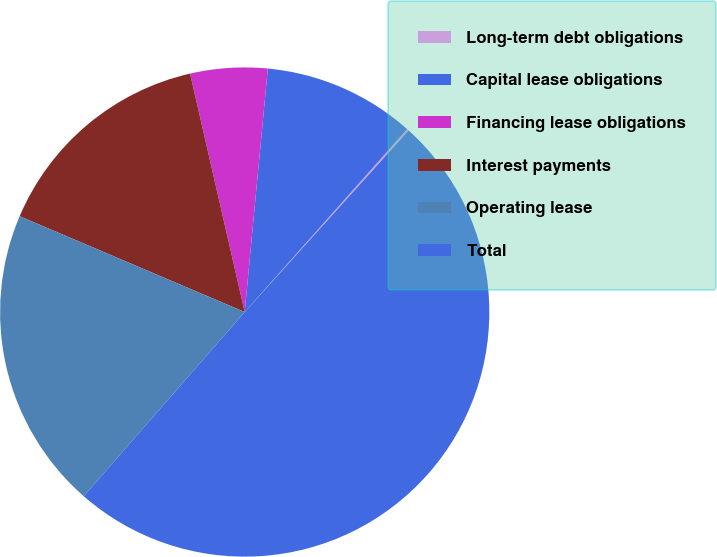Convert chart to OTSL. <chart><loc_0><loc_0><loc_500><loc_500><pie_chart><fcel>Long-term debt obligations<fcel>Capital lease obligations<fcel>Financing lease obligations<fcel>Interest payments<fcel>Operating lease<fcel>Total<nl><fcel>0.13%<fcel>10.05%<fcel>5.09%<fcel>15.01%<fcel>19.97%<fcel>49.74%<nl></chart> 